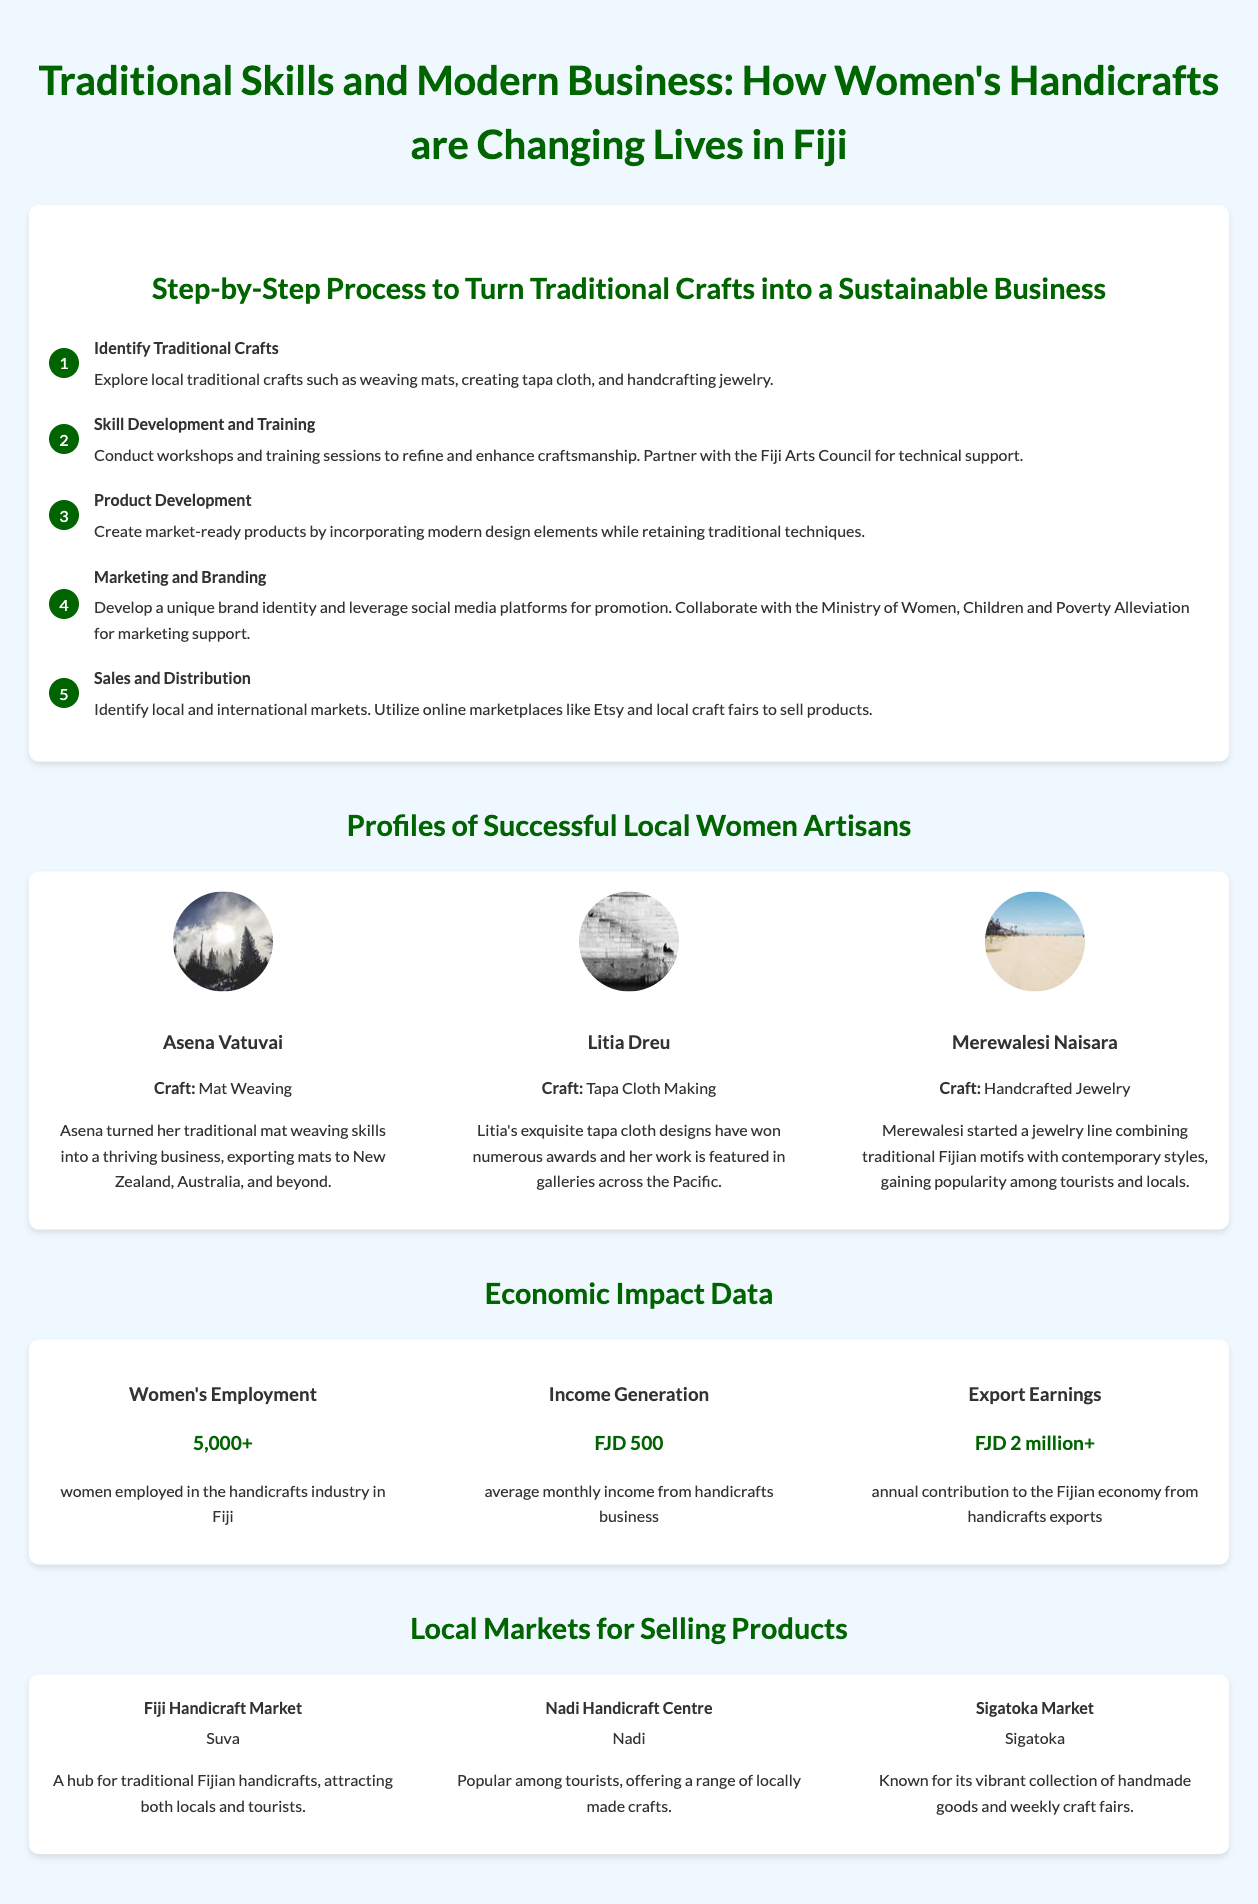What are the traditional crafts mentioned? The traditional crafts listed include weaving mats, creating tapa cloth, and handcrafting jewelry.
Answer: weaving mats, tapa cloth, jewelry What is the average monthly income from handicrafts? The document states the average monthly income from the handicrafts business is FJD 500.
Answer: FJD 500 Who is Litia Dreu? Litia Dreu is a successful artisan known for her tapa cloth making skills and award-winning designs.
Answer: Litia Dreu How many women are employed in the handicrafts industry in Fiji? According to the document, there are over 5,000 women employed in the handicrafts industry.
Answer: 5,000+ What is the economic contribution from handicrafts exports? The document indicates that the annual contribution to the Fijian economy from handicrafts exports is over FJD 2 million.
Answer: FJD 2 million+ What is the purpose of skill development and training? The purpose is to refine and enhance craftsmanship by conducting workshops and training sessions.
Answer: refine and enhance craftsmanship Which market is known for handmade goods and craft fairs? The Sigatoka Market is recognized for its vibrant collection of handmade goods and weekly craft fairs.
Answer: Sigatoka Market What is one way artisans can market their products? Artisans can leverage social media platforms for promotion as one of the marketing strategies.
Answer: social media platforms Who provides technical support for artisans during skill development? The Fiji Arts Council is mentioned as a partner for providing technical support.
Answer: Fiji Arts Council 